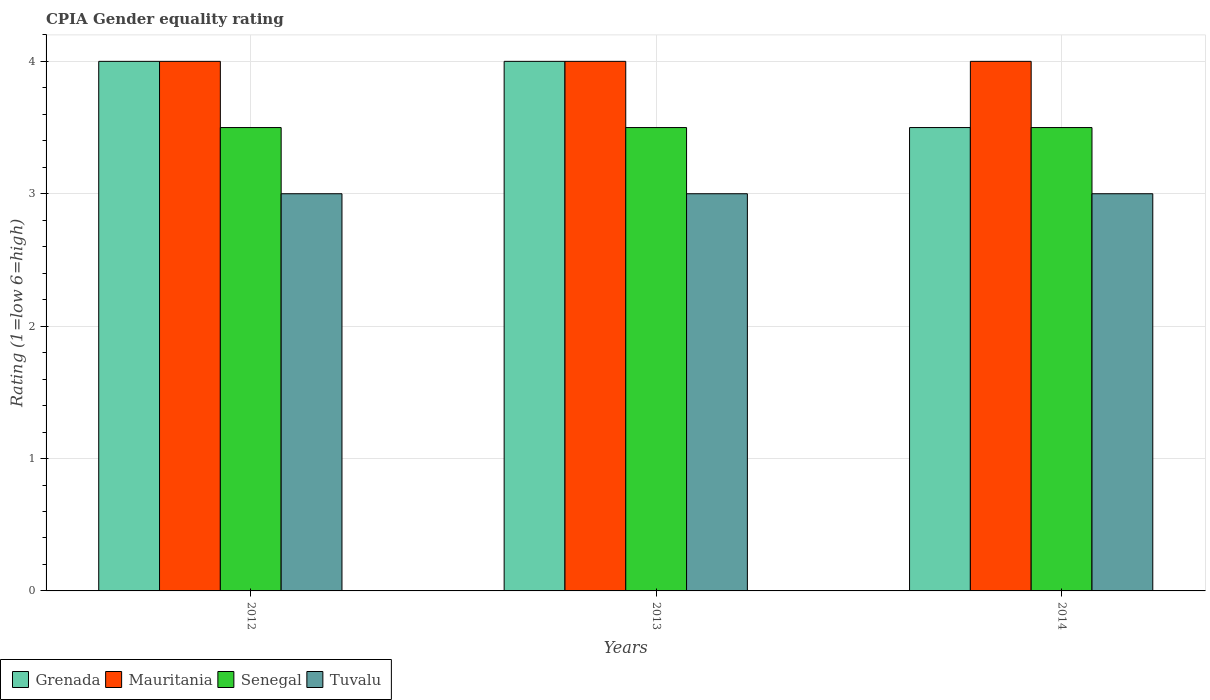How many different coloured bars are there?
Your answer should be very brief. 4. How many bars are there on the 1st tick from the left?
Give a very brief answer. 4. What is the label of the 2nd group of bars from the left?
Make the answer very short. 2013. In how many cases, is the number of bars for a given year not equal to the number of legend labels?
Keep it short and to the point. 0. Across all years, what is the maximum CPIA rating in Tuvalu?
Your answer should be compact. 3. In which year was the CPIA rating in Mauritania minimum?
Ensure brevity in your answer.  2012. What is the difference between the CPIA rating in Grenada in 2013 and that in 2014?
Provide a succinct answer. 0.5. What is the average CPIA rating in Tuvalu per year?
Ensure brevity in your answer.  3. In the year 2012, what is the difference between the CPIA rating in Tuvalu and CPIA rating in Senegal?
Keep it short and to the point. -0.5. What is the ratio of the CPIA rating in Tuvalu in 2012 to that in 2013?
Ensure brevity in your answer.  1. Is the difference between the CPIA rating in Tuvalu in 2013 and 2014 greater than the difference between the CPIA rating in Senegal in 2013 and 2014?
Provide a short and direct response. No. What is the difference between the highest and the second highest CPIA rating in Tuvalu?
Give a very brief answer. 0. What does the 1st bar from the left in 2012 represents?
Keep it short and to the point. Grenada. What does the 1st bar from the right in 2014 represents?
Give a very brief answer. Tuvalu. How many years are there in the graph?
Your answer should be compact. 3. What is the difference between two consecutive major ticks on the Y-axis?
Keep it short and to the point. 1. Are the values on the major ticks of Y-axis written in scientific E-notation?
Your answer should be very brief. No. Does the graph contain any zero values?
Offer a terse response. No. Where does the legend appear in the graph?
Offer a very short reply. Bottom left. How are the legend labels stacked?
Provide a succinct answer. Horizontal. What is the title of the graph?
Provide a short and direct response. CPIA Gender equality rating. Does "San Marino" appear as one of the legend labels in the graph?
Your answer should be very brief. No. What is the label or title of the Y-axis?
Provide a succinct answer. Rating (1=low 6=high). What is the Rating (1=low 6=high) in Senegal in 2012?
Offer a terse response. 3.5. What is the Rating (1=low 6=high) of Tuvalu in 2012?
Keep it short and to the point. 3. What is the Rating (1=low 6=high) in Grenada in 2013?
Your response must be concise. 4. What is the Rating (1=low 6=high) of Mauritania in 2013?
Your answer should be compact. 4. What is the Rating (1=low 6=high) in Grenada in 2014?
Offer a very short reply. 3.5. What is the Rating (1=low 6=high) in Mauritania in 2014?
Provide a short and direct response. 4. What is the Rating (1=low 6=high) in Senegal in 2014?
Your response must be concise. 3.5. Across all years, what is the maximum Rating (1=low 6=high) in Grenada?
Keep it short and to the point. 4. Across all years, what is the minimum Rating (1=low 6=high) in Mauritania?
Make the answer very short. 4. Across all years, what is the minimum Rating (1=low 6=high) of Senegal?
Your answer should be compact. 3.5. Across all years, what is the minimum Rating (1=low 6=high) in Tuvalu?
Make the answer very short. 3. What is the total Rating (1=low 6=high) of Grenada in the graph?
Offer a very short reply. 11.5. What is the total Rating (1=low 6=high) of Mauritania in the graph?
Give a very brief answer. 12. What is the total Rating (1=low 6=high) of Senegal in the graph?
Offer a terse response. 10.5. What is the total Rating (1=low 6=high) of Tuvalu in the graph?
Ensure brevity in your answer.  9. What is the difference between the Rating (1=low 6=high) of Mauritania in 2012 and that in 2013?
Provide a short and direct response. 0. What is the difference between the Rating (1=low 6=high) of Senegal in 2012 and that in 2013?
Make the answer very short. 0. What is the difference between the Rating (1=low 6=high) in Grenada in 2012 and that in 2014?
Your response must be concise. 0.5. What is the difference between the Rating (1=low 6=high) in Mauritania in 2012 and that in 2014?
Make the answer very short. 0. What is the difference between the Rating (1=low 6=high) in Mauritania in 2013 and that in 2014?
Provide a short and direct response. 0. What is the difference between the Rating (1=low 6=high) of Tuvalu in 2013 and that in 2014?
Your answer should be very brief. 0. What is the difference between the Rating (1=low 6=high) of Senegal in 2012 and the Rating (1=low 6=high) of Tuvalu in 2013?
Your answer should be very brief. 0.5. What is the difference between the Rating (1=low 6=high) of Grenada in 2012 and the Rating (1=low 6=high) of Mauritania in 2014?
Offer a very short reply. 0. What is the difference between the Rating (1=low 6=high) of Grenada in 2012 and the Rating (1=low 6=high) of Tuvalu in 2014?
Offer a very short reply. 1. What is the difference between the Rating (1=low 6=high) in Mauritania in 2012 and the Rating (1=low 6=high) in Senegal in 2014?
Ensure brevity in your answer.  0.5. What is the difference between the Rating (1=low 6=high) of Senegal in 2012 and the Rating (1=low 6=high) of Tuvalu in 2014?
Provide a short and direct response. 0.5. What is the difference between the Rating (1=low 6=high) of Grenada in 2013 and the Rating (1=low 6=high) of Mauritania in 2014?
Your answer should be compact. 0. What is the difference between the Rating (1=low 6=high) of Mauritania in 2013 and the Rating (1=low 6=high) of Senegal in 2014?
Your answer should be very brief. 0.5. What is the average Rating (1=low 6=high) of Grenada per year?
Provide a short and direct response. 3.83. What is the average Rating (1=low 6=high) in Senegal per year?
Offer a terse response. 3.5. What is the average Rating (1=low 6=high) in Tuvalu per year?
Offer a terse response. 3. In the year 2012, what is the difference between the Rating (1=low 6=high) in Grenada and Rating (1=low 6=high) in Senegal?
Your answer should be compact. 0.5. In the year 2012, what is the difference between the Rating (1=low 6=high) of Grenada and Rating (1=low 6=high) of Tuvalu?
Give a very brief answer. 1. In the year 2012, what is the difference between the Rating (1=low 6=high) in Mauritania and Rating (1=low 6=high) in Senegal?
Your response must be concise. 0.5. In the year 2012, what is the difference between the Rating (1=low 6=high) in Senegal and Rating (1=low 6=high) in Tuvalu?
Keep it short and to the point. 0.5. In the year 2013, what is the difference between the Rating (1=low 6=high) of Grenada and Rating (1=low 6=high) of Mauritania?
Ensure brevity in your answer.  0. In the year 2013, what is the difference between the Rating (1=low 6=high) in Grenada and Rating (1=low 6=high) in Tuvalu?
Offer a terse response. 1. In the year 2013, what is the difference between the Rating (1=low 6=high) in Mauritania and Rating (1=low 6=high) in Senegal?
Provide a short and direct response. 0.5. In the year 2014, what is the difference between the Rating (1=low 6=high) in Grenada and Rating (1=low 6=high) in Mauritania?
Offer a terse response. -0.5. What is the ratio of the Rating (1=low 6=high) of Senegal in 2012 to that in 2013?
Keep it short and to the point. 1. What is the ratio of the Rating (1=low 6=high) in Grenada in 2013 to that in 2014?
Keep it short and to the point. 1.14. What is the ratio of the Rating (1=low 6=high) of Senegal in 2013 to that in 2014?
Your response must be concise. 1. What is the difference between the highest and the second highest Rating (1=low 6=high) in Grenada?
Keep it short and to the point. 0. What is the difference between the highest and the second highest Rating (1=low 6=high) of Tuvalu?
Your answer should be very brief. 0. What is the difference between the highest and the lowest Rating (1=low 6=high) of Grenada?
Provide a short and direct response. 0.5. What is the difference between the highest and the lowest Rating (1=low 6=high) in Mauritania?
Keep it short and to the point. 0. What is the difference between the highest and the lowest Rating (1=low 6=high) of Senegal?
Keep it short and to the point. 0. 